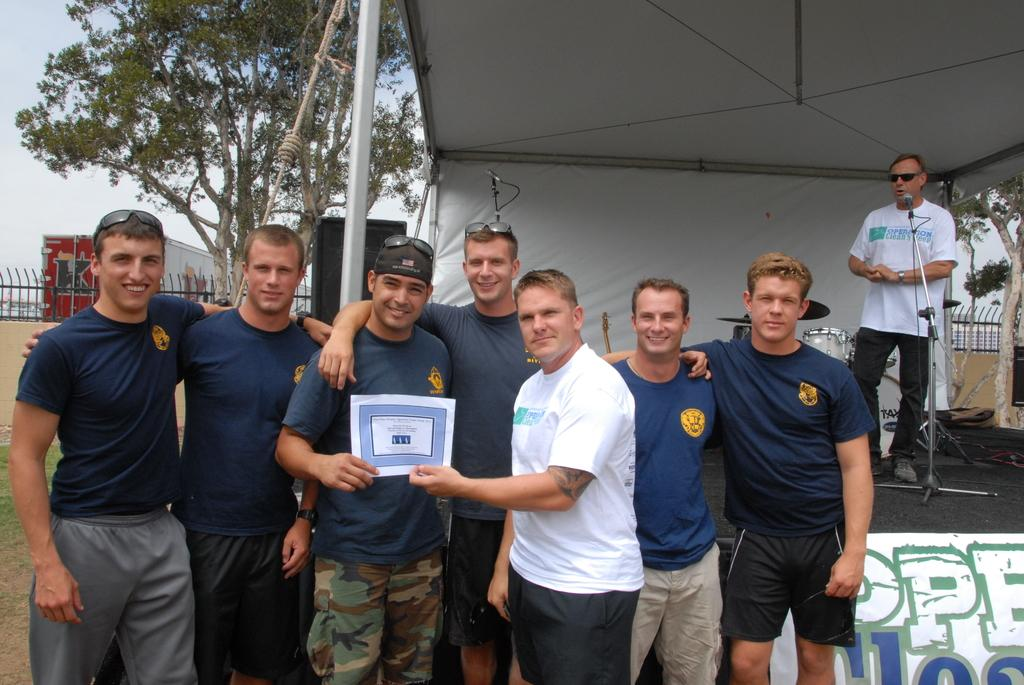What is the main activity of the group of persons in the image? The provided facts do not specify the main activity of the group of persons. What structure can be seen in the background of the image? There is a tent in the background of the image. Can you describe the person in the background? There is a person in the background, but no specific details are provided about them. What equipment is present in the background that might be used for amplifying sound? There is a mic and a speaker in the background that might be used for amplifying sound. What type of musical instruments are visible in the background? There are musical instruments in the background, but no specific details are provided about them. What natural element can be seen in the background of the image? There is a tree in the background of the image. What architectural feature is present in the background? There is fencing in the background of the image. What type of vehicle is visible in the background? There is a truck in the background of the image. What is visible in the sky in the background of the image? The sky is visible in the background of the image. How many snails are crawling on the lip of the person in the image? There are no snails visible in the image, and no mention of a lip on any person in the image. 